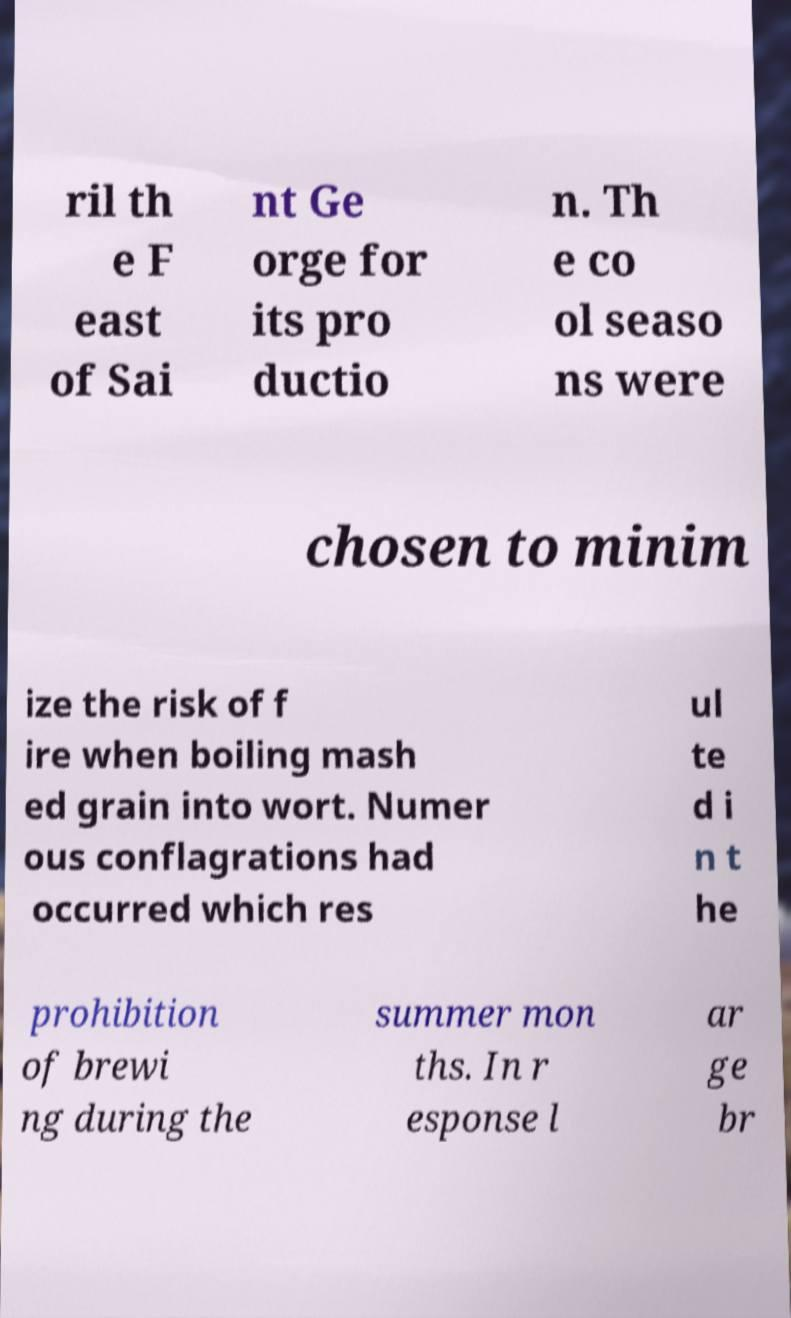There's text embedded in this image that I need extracted. Can you transcribe it verbatim? ril th e F east of Sai nt Ge orge for its pro ductio n. Th e co ol seaso ns were chosen to minim ize the risk of f ire when boiling mash ed grain into wort. Numer ous conflagrations had occurred which res ul te d i n t he prohibition of brewi ng during the summer mon ths. In r esponse l ar ge br 